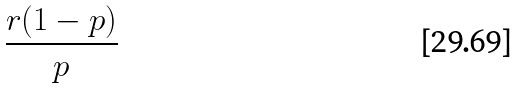Convert formula to latex. <formula><loc_0><loc_0><loc_500><loc_500>\frac { r ( 1 - p ) } { p }</formula> 